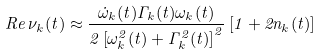<formula> <loc_0><loc_0><loc_500><loc_500>R e \, \nu _ { k } ( t ) \approx \frac { \dot { \omega } _ { k } ( t ) \Gamma _ { k } ( t ) \omega _ { k } ( t ) } { 2 \left [ \omega _ { k } ^ { 2 } ( t ) + \Gamma _ { k } ^ { 2 } ( t ) \right ] ^ { 2 } } \left [ 1 + 2 n _ { k } ( t ) \right ]</formula> 